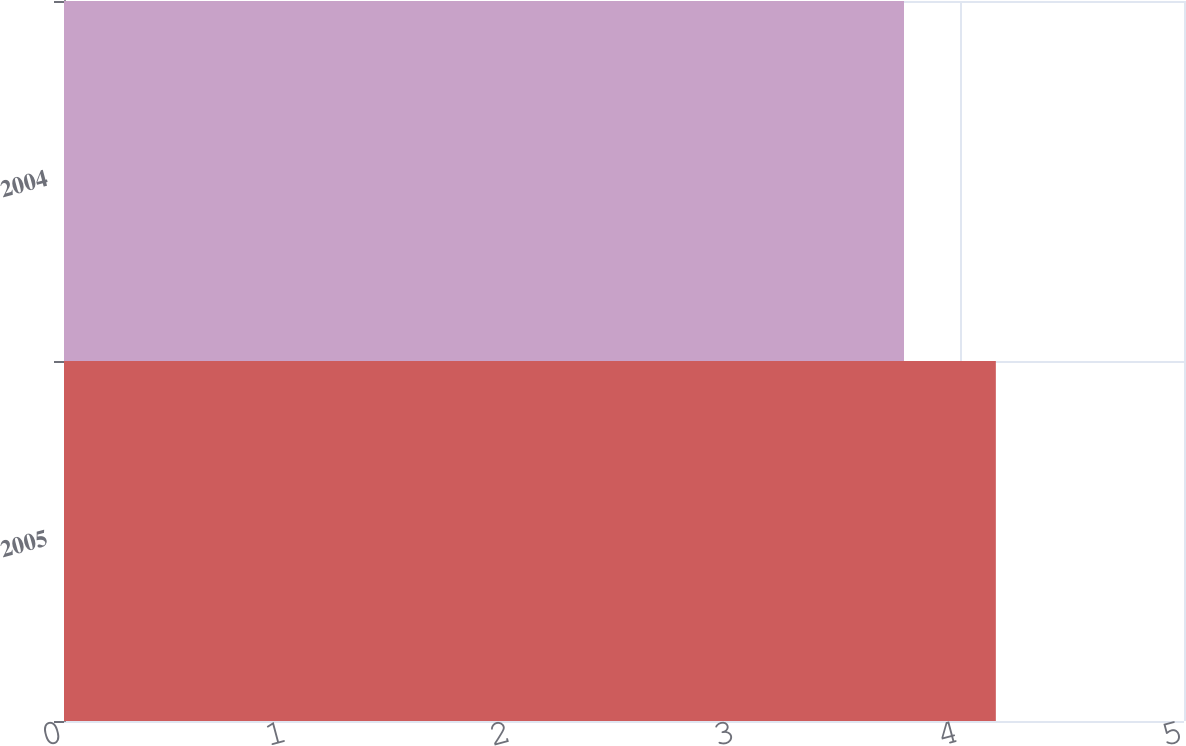Convert chart. <chart><loc_0><loc_0><loc_500><loc_500><bar_chart><fcel>2005<fcel>2004<nl><fcel>4.16<fcel>3.75<nl></chart> 